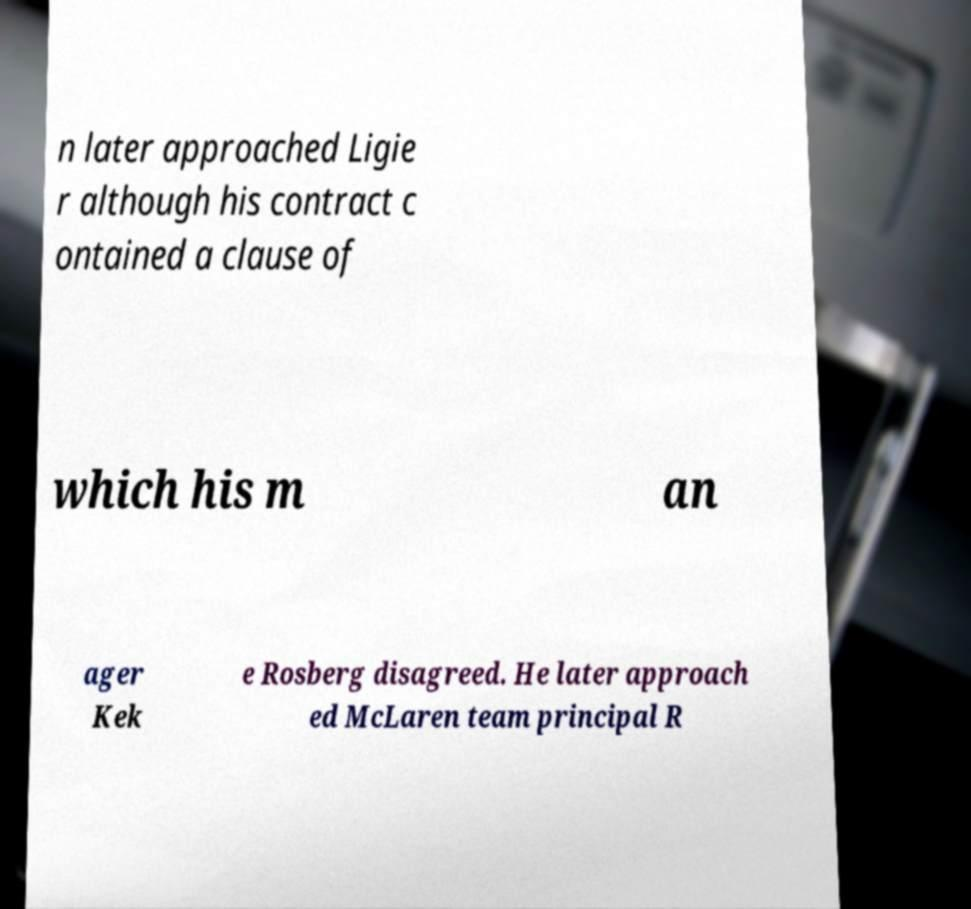What messages or text are displayed in this image? I need them in a readable, typed format. n later approached Ligie r although his contract c ontained a clause of which his m an ager Kek e Rosberg disagreed. He later approach ed McLaren team principal R 